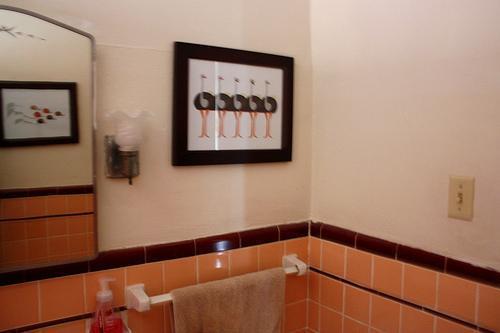How many frames?
Give a very brief answer. 2. 